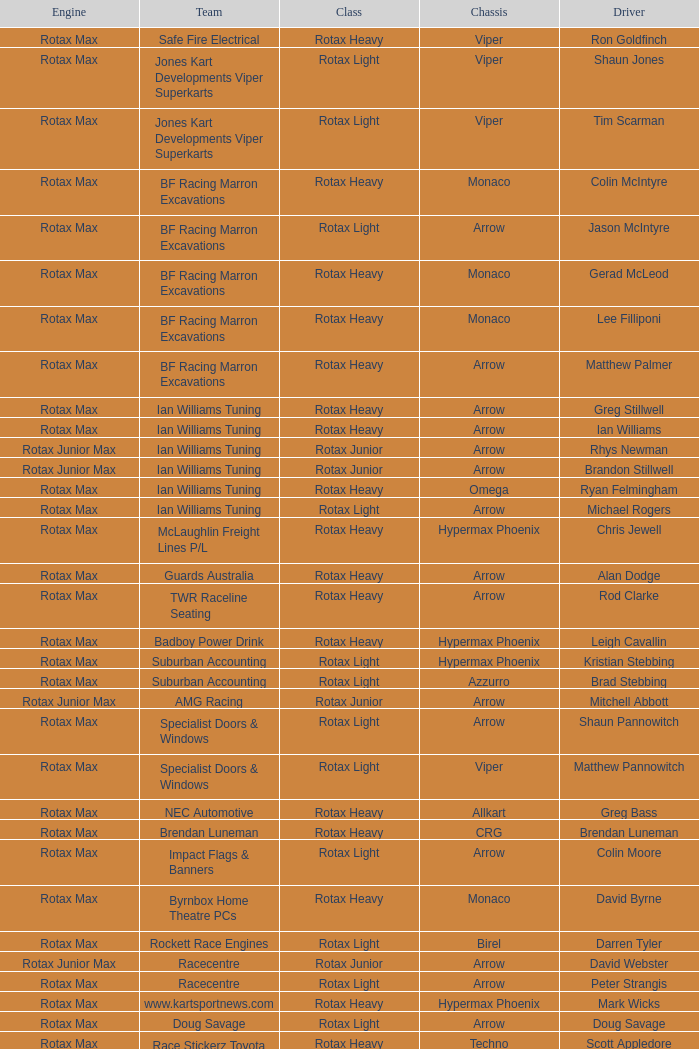Driver Shaun Jones with a viper as a chassis is in what class? Rotax Light. 